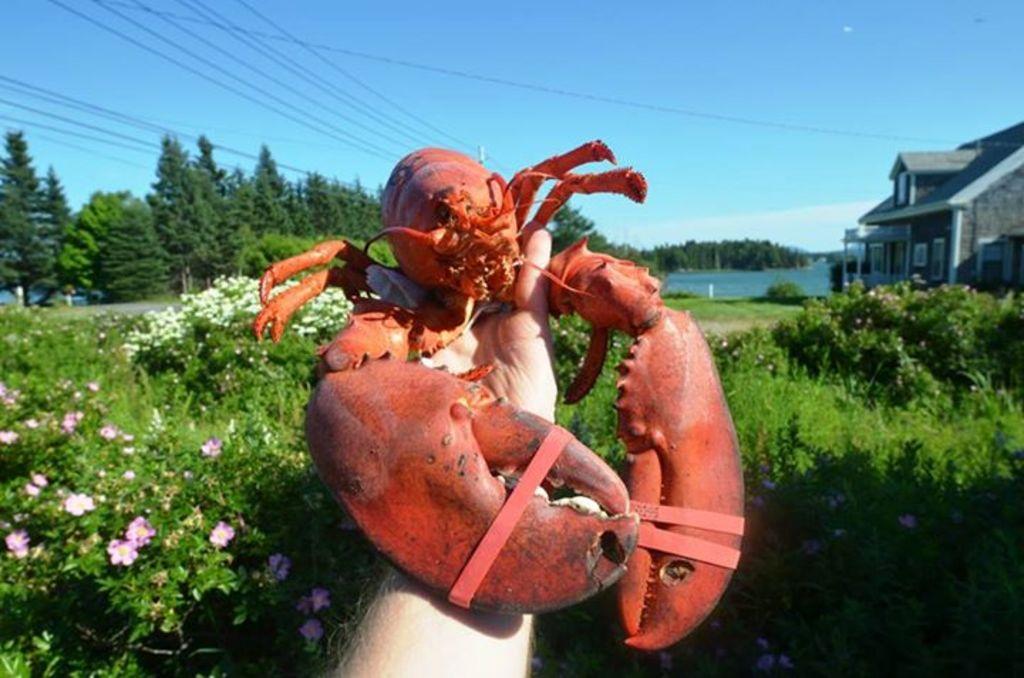Could you give a brief overview of what you see in this image? In the center of the image we can see the hand of a person holding a lobster. We can also see a group of plants with flowers, a house with roof and windows, a group of trees, wires, a water body and the sky which looks cloudy. 